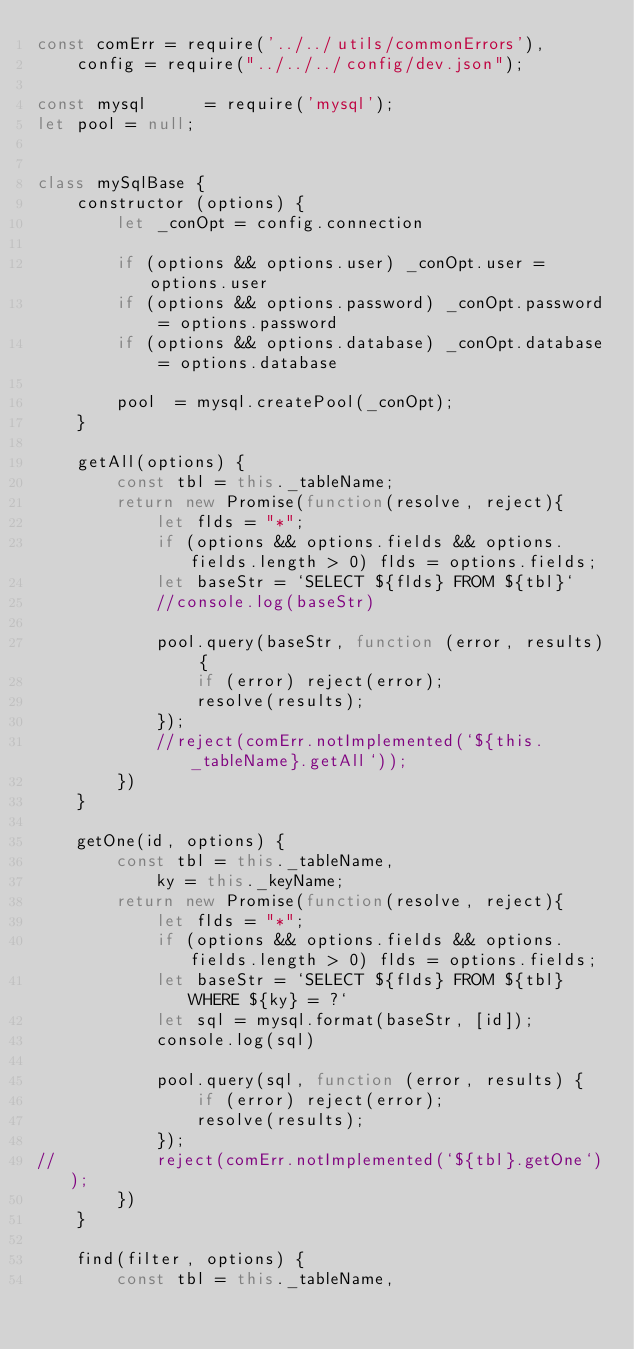<code> <loc_0><loc_0><loc_500><loc_500><_JavaScript_>const comErr = require('../../utils/commonErrors'),
	config = require("../../../config/dev.json");

const mysql      = require('mysql');
let pool = null;


class mySqlBase {
	constructor (options) {
		let _conOpt = config.connection

		if (options && options.user) _conOpt.user = options.user
		if (options && options.password) _conOpt.password = options.password
		if (options && options.database) _conOpt.database = options.database
        
		pool  = mysql.createPool(_conOpt);	
	}

	getAll(options) {
		const tbl = this._tableName;
		return new Promise(function(resolve, reject){
			let flds = "*";
			if (options && options.fields && options.fields.length > 0) flds = options.fields;
			let baseStr = `SELECT ${flds} FROM ${tbl}`
			//console.log(baseStr)

			pool.query(baseStr, function (error, results) {
				if (error) reject(error);
				resolve(results);
			});
			//reject(comErr.notImplemented(`${this._tableName}.getAll`));
		})
	}

	getOne(id, options) {
		const tbl = this._tableName,
			ky = this._keyName;
		return new Promise(function(resolve, reject){
			let flds = "*";
			if (options && options.fields && options.fields.length > 0) flds = options.fields;
			let baseStr = `SELECT ${flds} FROM ${tbl} WHERE ${ky} = ?`
			let sql = mysql.format(baseStr, [id]);
			console.log(sql)

			pool.query(sql, function (error, results) {
				if (error) reject(error);
				resolve(results);
			});
//			reject(comErr.notImplemented(`${tbl}.getOne`));
		})
	}

	find(filter, options) {
		const tbl = this._tableName,</code> 